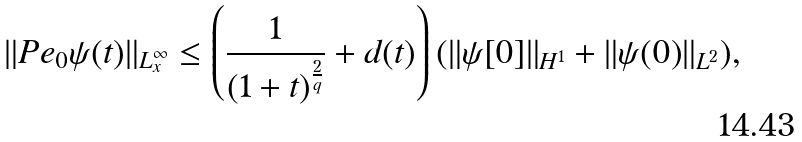<formula> <loc_0><loc_0><loc_500><loc_500>\| P e _ { 0 } \psi ( t ) \| _ { L _ { x } ^ { \infty } } \leq \left ( \frac { 1 } { { ( 1 + t ) } ^ { \frac { 2 } { q } } } + d ( t ) \right ) ( \| \psi [ 0 ] \| _ { H ^ { 1 } } + \| \psi ( 0 ) \| _ { L ^ { 2 } } ) ,</formula> 